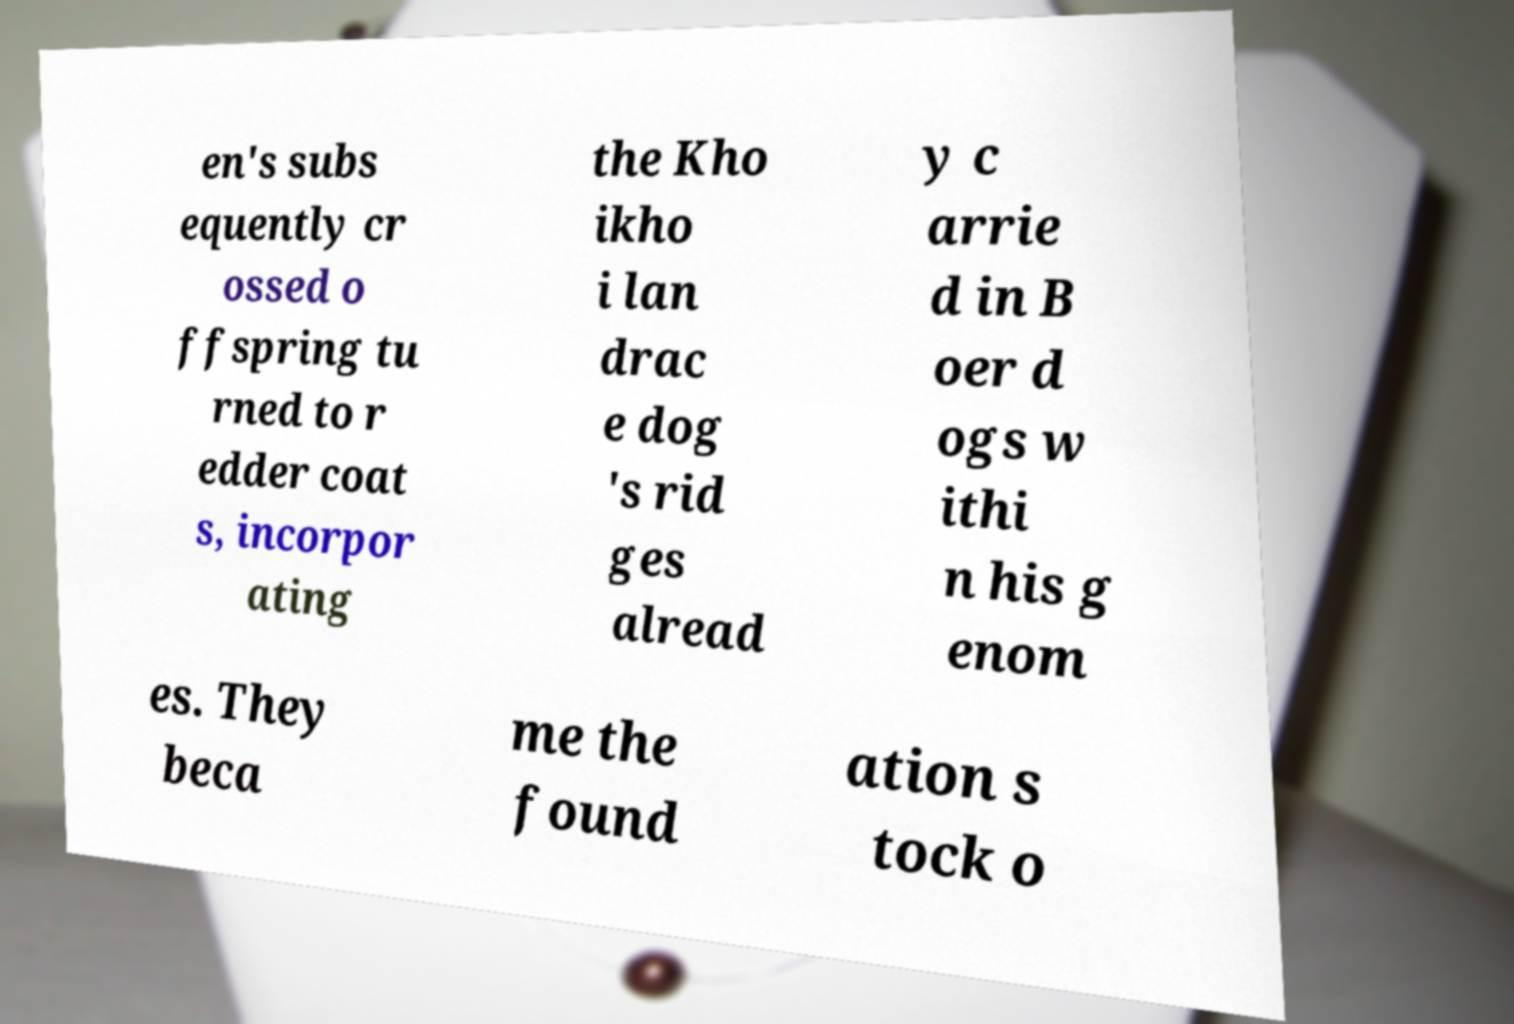What messages or text are displayed in this image? I need them in a readable, typed format. en's subs equently cr ossed o ffspring tu rned to r edder coat s, incorpor ating the Kho ikho i lan drac e dog 's rid ges alread y c arrie d in B oer d ogs w ithi n his g enom es. They beca me the found ation s tock o 